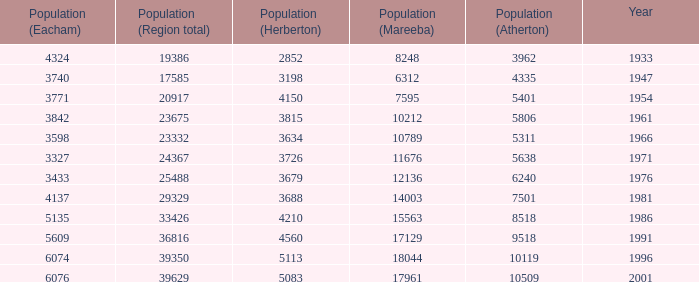Could you parse the entire table? {'header': ['Population (Eacham)', 'Population (Region total)', 'Population (Herberton)', 'Population (Mareeba)', 'Population (Atherton)', 'Year'], 'rows': [['4324', '19386', '2852', '8248', '3962', '1933'], ['3740', '17585', '3198', '6312', '4335', '1947'], ['3771', '20917', '4150', '7595', '5401', '1954'], ['3842', '23675', '3815', '10212', '5806', '1961'], ['3598', '23332', '3634', '10789', '5311', '1966'], ['3327', '24367', '3726', '11676', '5638', '1971'], ['3433', '25488', '3679', '12136', '6240', '1976'], ['4137', '29329', '3688', '14003', '7501', '1981'], ['5135', '33426', '4210', '15563', '8518', '1986'], ['5609', '36816', '4560', '17129', '9518', '1991'], ['6074', '39350', '5113', '18044', '10119', '1996'], ['6076', '39629', '5083', '17961', '10509', '2001']]} What was the smallest population figure for Mareeba? 6312.0. 